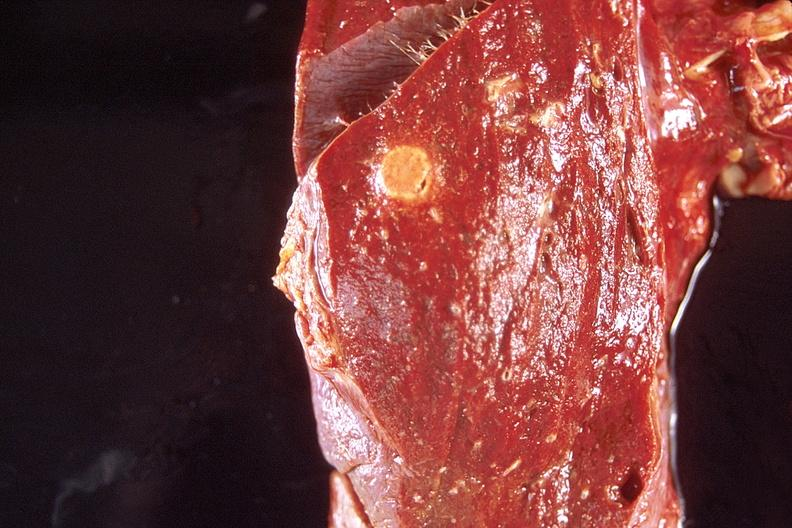s dilantin present?
Answer the question using a single word or phrase. No 